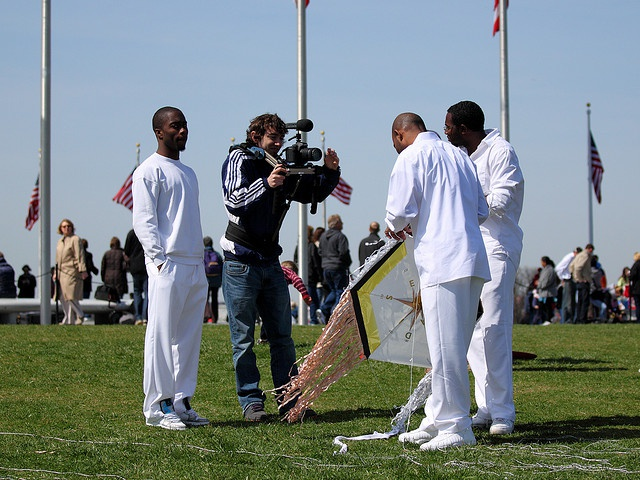Describe the objects in this image and their specific colors. I can see people in darkgray, lavender, and gray tones, people in darkgray, black, gray, lightgray, and navy tones, people in darkgray, gray, and lavender tones, kite in darkgray, gray, olive, and black tones, and people in darkgray, gray, lavender, and black tones in this image. 